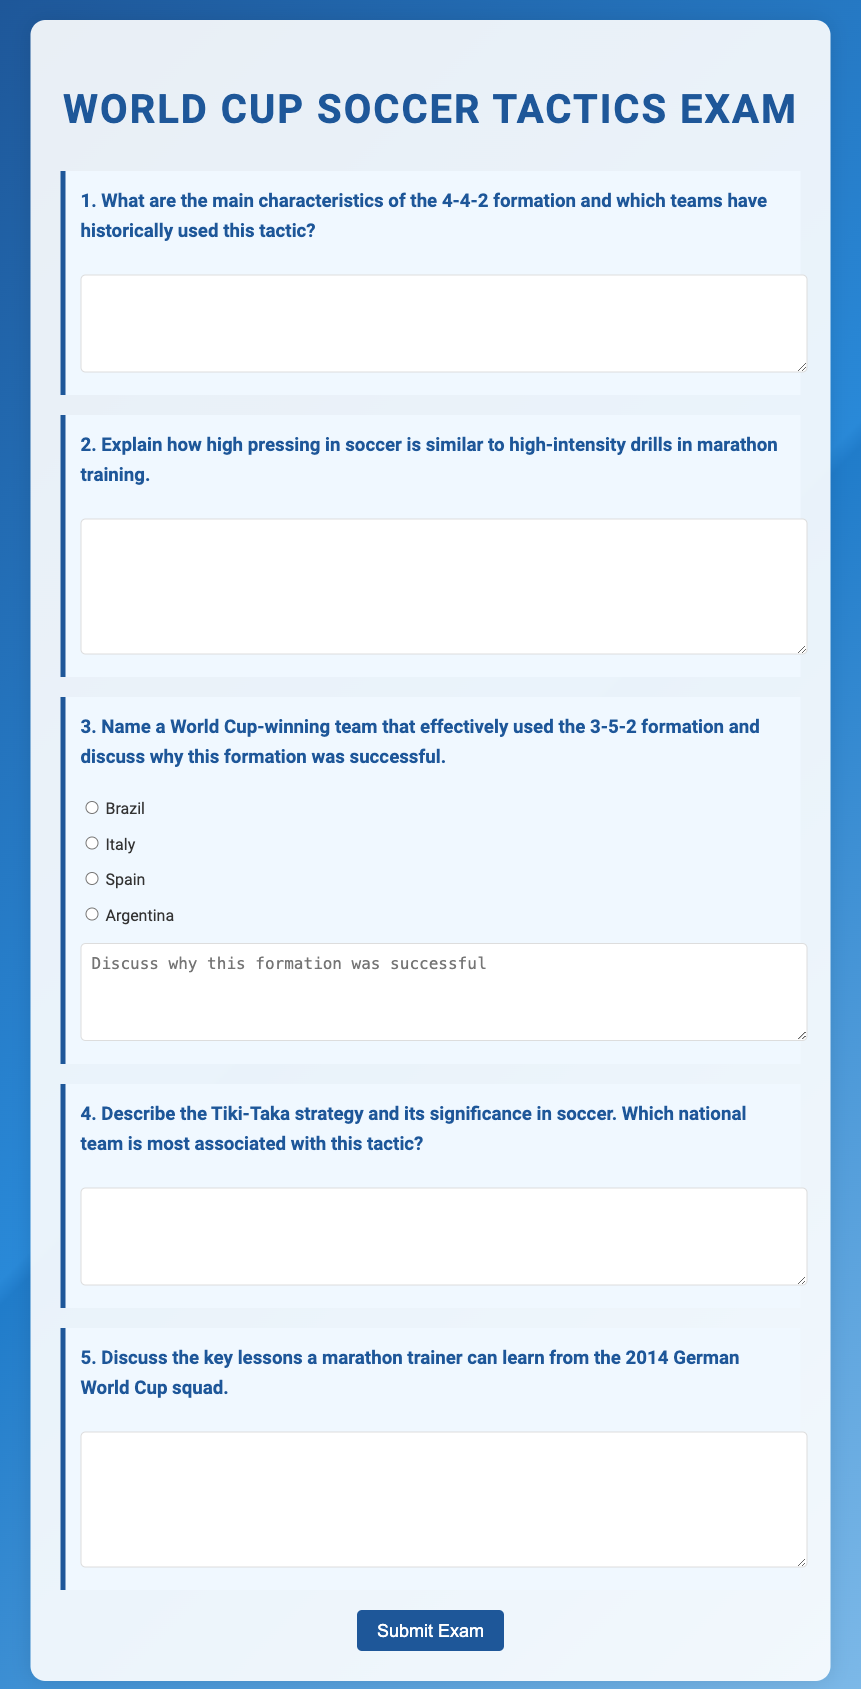What is the title of the exam? The title of the exam is stated prominently at the top of the document.
Answer: World Cup Soccer Tactics Exam What formation is discussed in question 1? The formation mentioned in question 1 is explicitly stated in the question itself.
Answer: 4-4-2 Which national team is most associated with the Tiki-Taka strategy? The significance of the Tiki-Taka strategy and its association with a national team is directly addressed in the text of question 4.
Answer: Spanish national team How many questions are there in the exam? The total number of questions can be counted by reviewing the numbered questions in the document.
Answer: 5 What type of strategy is mentioned in question 4? The strategy referred to in question 4 is clearly defined and can be identified directly in the question.
Answer: Tiki-Taka In which year did the German World Cup squad mentioned in question 5 win? The German World Cup squad mentioned in question 5 refers to a specific event that occurred in 2014.
Answer: 2014 